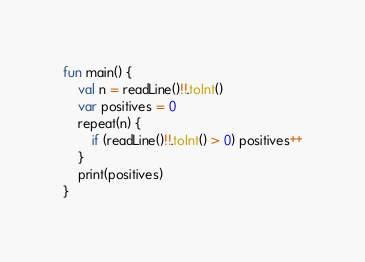Convert code to text. <code><loc_0><loc_0><loc_500><loc_500><_Kotlin_>fun main() {
    val n = readLine()!!.toInt()
    var positives = 0
    repeat(n) {
        if (readLine()!!.toInt() > 0) positives++
    }
    print(positives)
}</code> 